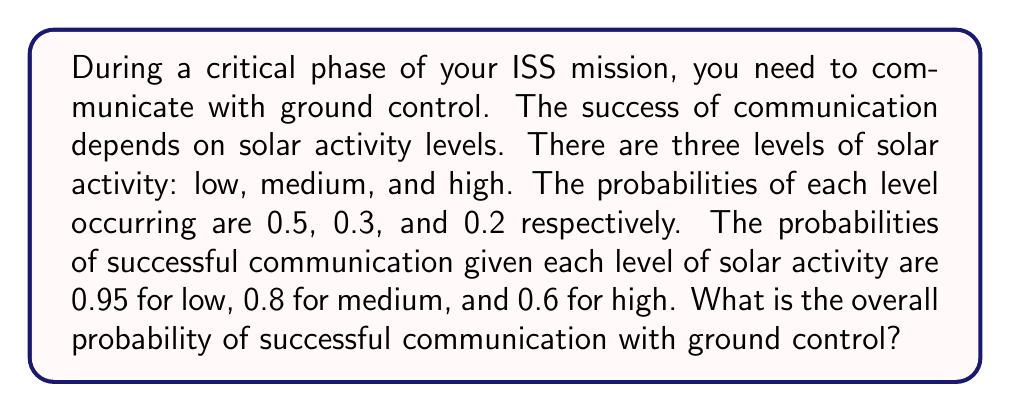Provide a solution to this math problem. Let's approach this step-by-step using the Law of Total Probability:

1) Define events:
   S: Successful communication
   L: Low solar activity
   M: Medium solar activity
   H: High solar activity

2) Given probabilities:
   $P(L) = 0.5$, $P(M) = 0.3$, $P(H) = 0.2$
   $P(S|L) = 0.95$, $P(S|M) = 0.8$, $P(S|H) = 0.6$

3) Law of Total Probability:
   $$P(S) = P(S|L)P(L) + P(S|M)P(M) + P(S|H)P(H)$$

4) Substitute the values:
   $$P(S) = (0.95)(0.5) + (0.8)(0.3) + (0.6)(0.2)$$

5) Calculate:
   $$P(S) = 0.475 + 0.24 + 0.12 = 0.835$$

Thus, the overall probability of successful communication is 0.835 or 83.5%.
Answer: 0.835 